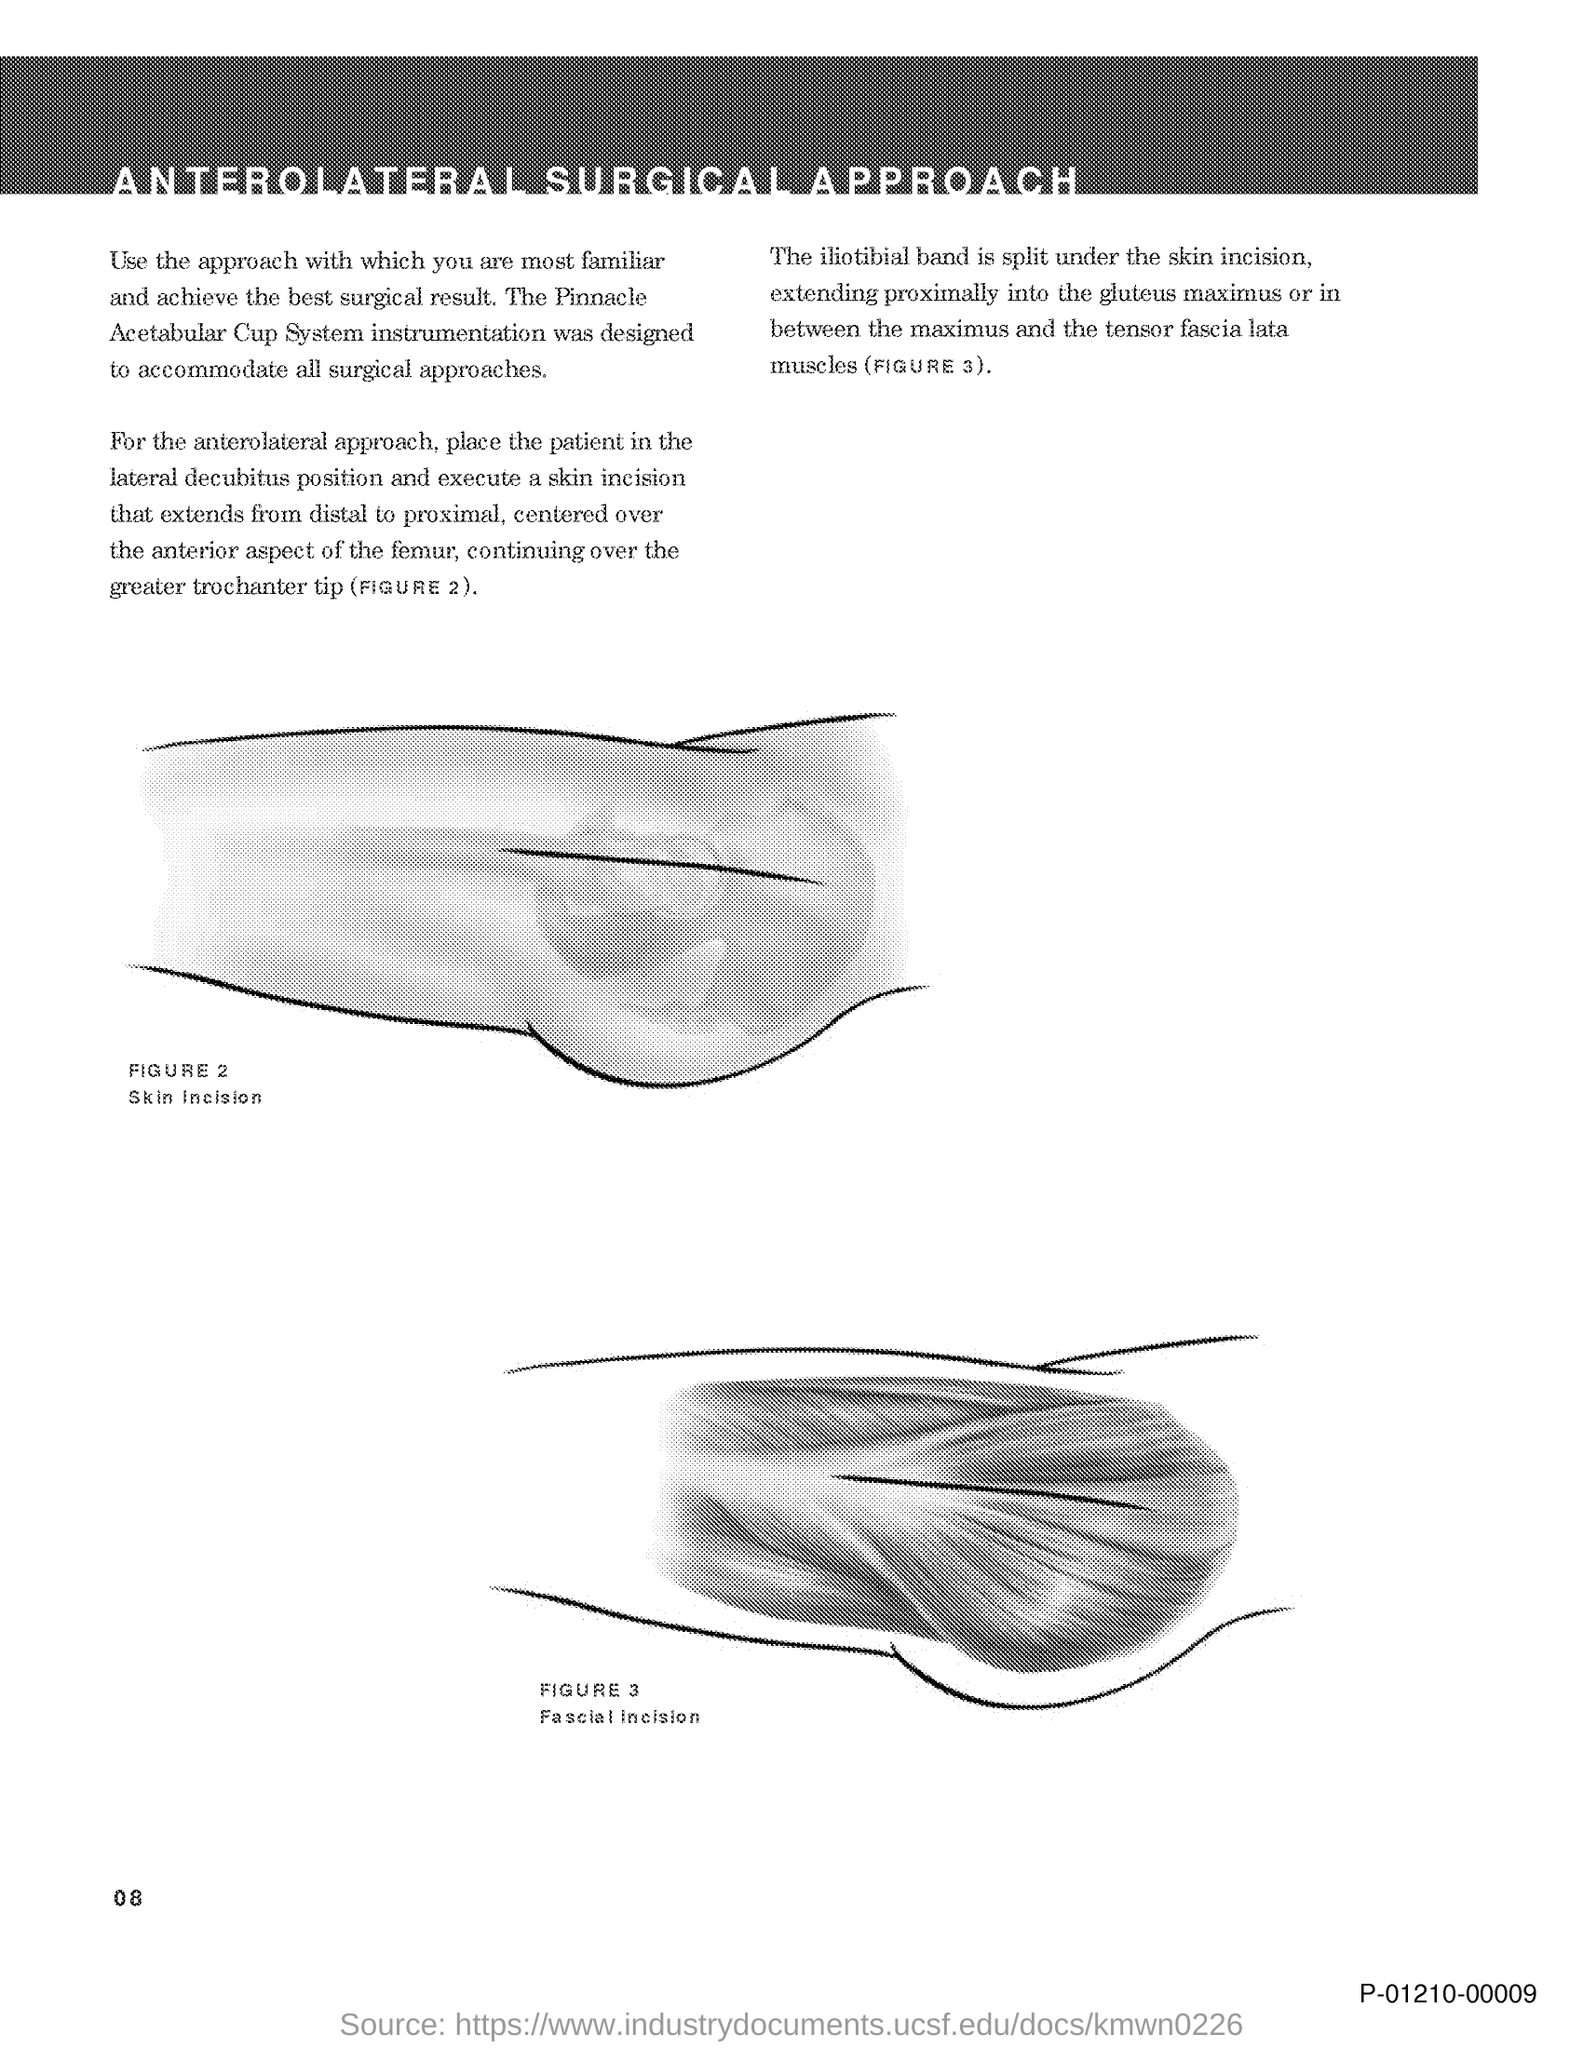Give some essential details in this illustration. The document is titled 'Anterolateral Surgical Approach.' 